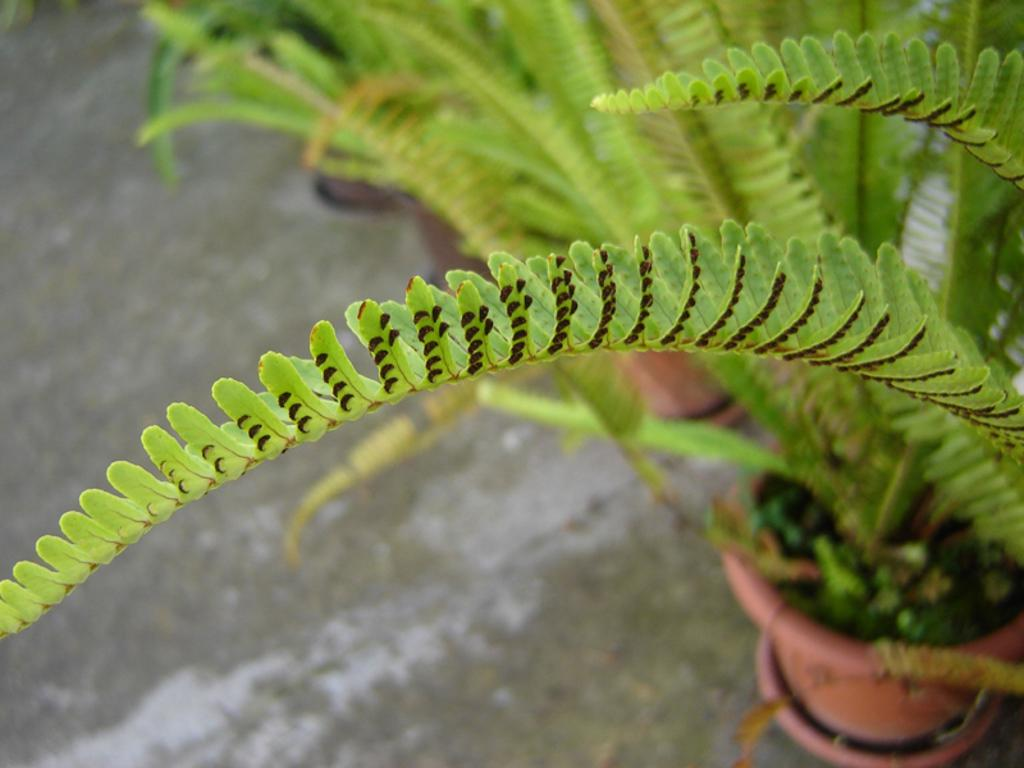What type of plant material is visible on the right side of the image? There are leaves of a plant on the right side of the image. Can you describe the plants in the background of the image? There are plants in pots on the ground in the background of the image. What is the reaction of the plant when it is bitten by an insect in the image? There is no insect or reaction visible in the image; it only shows plant leaves and plants in pots. 